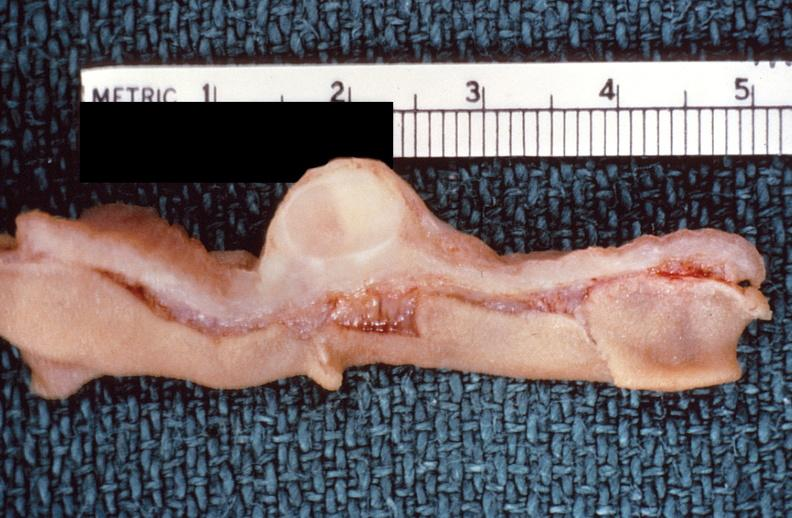s normal ovary present?
Answer the question using a single word or phrase. No 